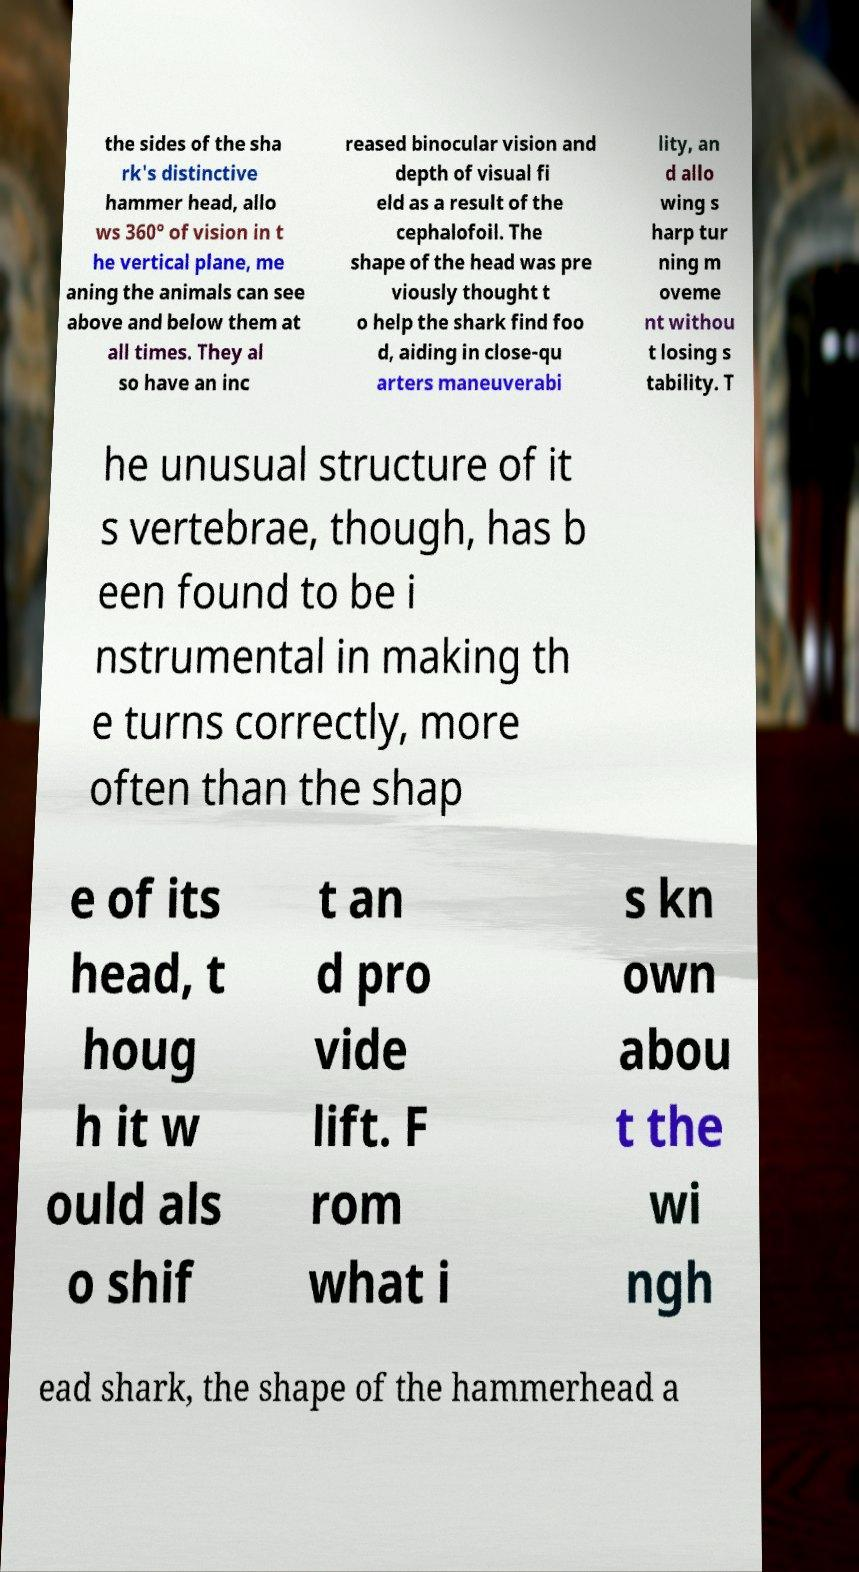For documentation purposes, I need the text within this image transcribed. Could you provide that? the sides of the sha rk's distinctive hammer head, allo ws 360° of vision in t he vertical plane, me aning the animals can see above and below them at all times. They al so have an inc reased binocular vision and depth of visual fi eld as a result of the cephalofoil. The shape of the head was pre viously thought t o help the shark find foo d, aiding in close-qu arters maneuverabi lity, an d allo wing s harp tur ning m oveme nt withou t losing s tability. T he unusual structure of it s vertebrae, though, has b een found to be i nstrumental in making th e turns correctly, more often than the shap e of its head, t houg h it w ould als o shif t an d pro vide lift. F rom what i s kn own abou t the wi ngh ead shark, the shape of the hammerhead a 